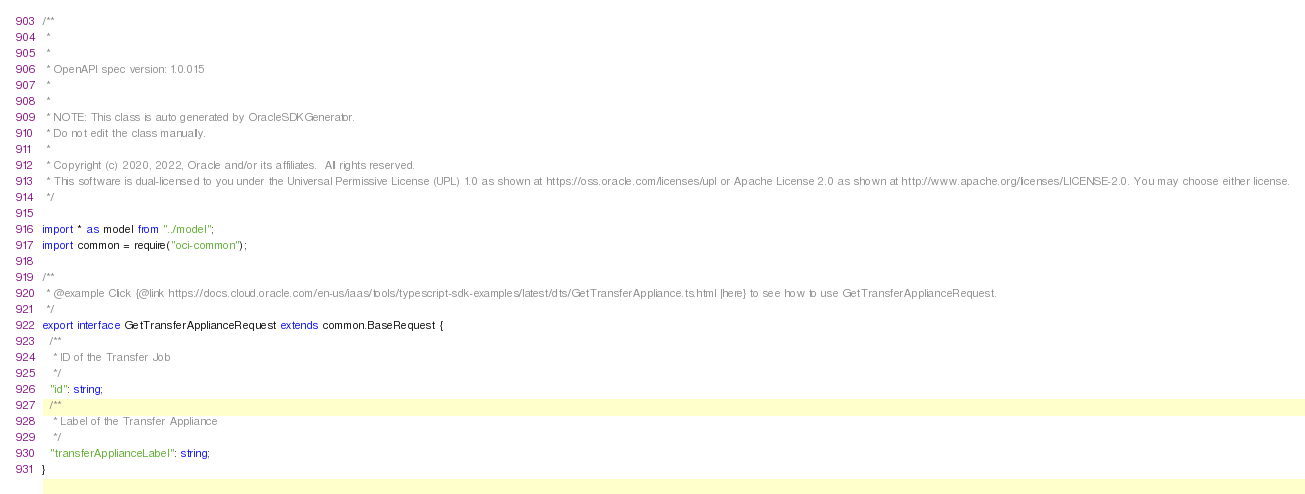Convert code to text. <code><loc_0><loc_0><loc_500><loc_500><_TypeScript_>/**
 *
 *
 * OpenAPI spec version: 1.0.015
 *
 *
 * NOTE: This class is auto generated by OracleSDKGenerator.
 * Do not edit the class manually.
 *
 * Copyright (c) 2020, 2022, Oracle and/or its affiliates.  All rights reserved.
 * This software is dual-licensed to you under the Universal Permissive License (UPL) 1.0 as shown at https://oss.oracle.com/licenses/upl or Apache License 2.0 as shown at http://www.apache.org/licenses/LICENSE-2.0. You may choose either license.
 */

import * as model from "../model";
import common = require("oci-common");

/**
 * @example Click {@link https://docs.cloud.oracle.com/en-us/iaas/tools/typescript-sdk-examples/latest/dts/GetTransferAppliance.ts.html |here} to see how to use GetTransferApplianceRequest.
 */
export interface GetTransferApplianceRequest extends common.BaseRequest {
  /**
   * ID of the Transfer Job
   */
  "id": string;
  /**
   * Label of the Transfer Appliance
   */
  "transferApplianceLabel": string;
}
</code> 